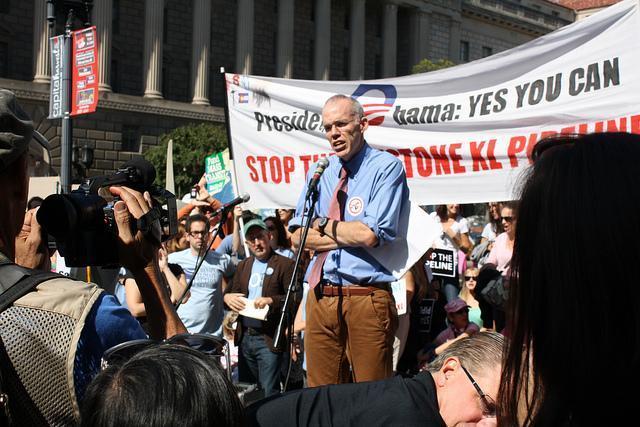How many people are visible?
Give a very brief answer. 8. 